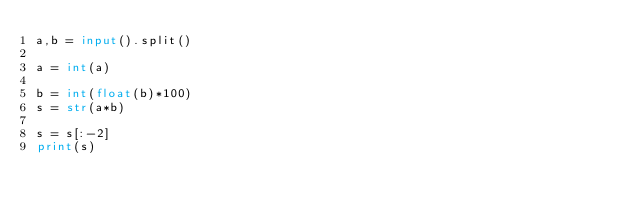<code> <loc_0><loc_0><loc_500><loc_500><_Python_>a,b = input().split()

a = int(a)

b = int(float(b)*100)
s = str(a*b)

s = s[:-2]
print(s)
</code> 